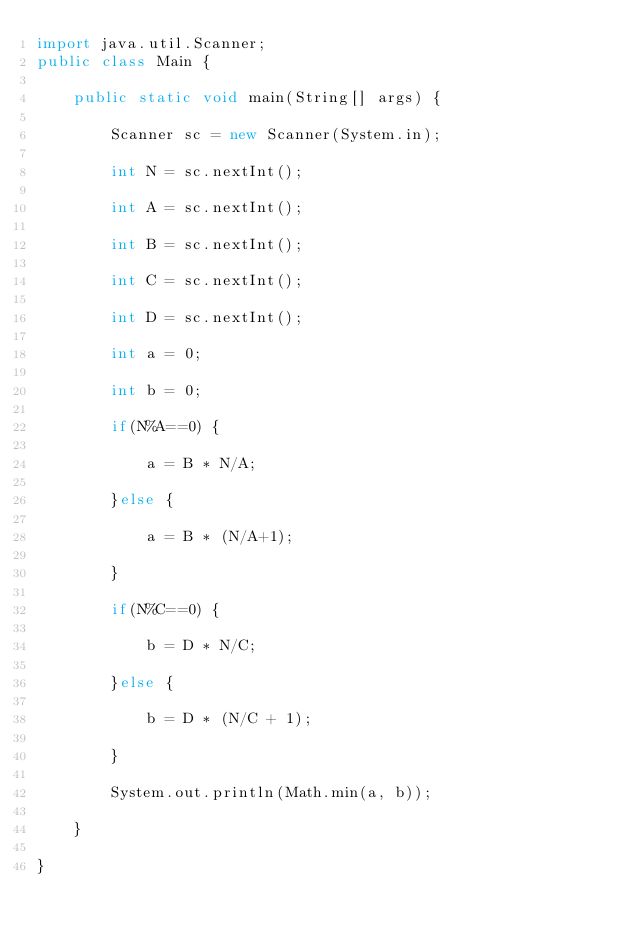<code> <loc_0><loc_0><loc_500><loc_500><_Java_>import java.util.Scanner;
public class Main {

	public static void main(String[] args) {

		Scanner sc = new Scanner(System.in);

		int N = sc.nextInt();

		int A = sc.nextInt();

		int B = sc.nextInt();

		int C = sc.nextInt();

		int D = sc.nextInt();

		int a = 0;

		int b = 0;

		if(N%A==0) {

			a = B * N/A;

		}else {

			a = B * (N/A+1);

		}

		if(N%C==0) {

			b = D * N/C;

		}else {

			b = D * (N/C + 1);

		}

		System.out.println(Math.min(a, b));

	}

}

</code> 